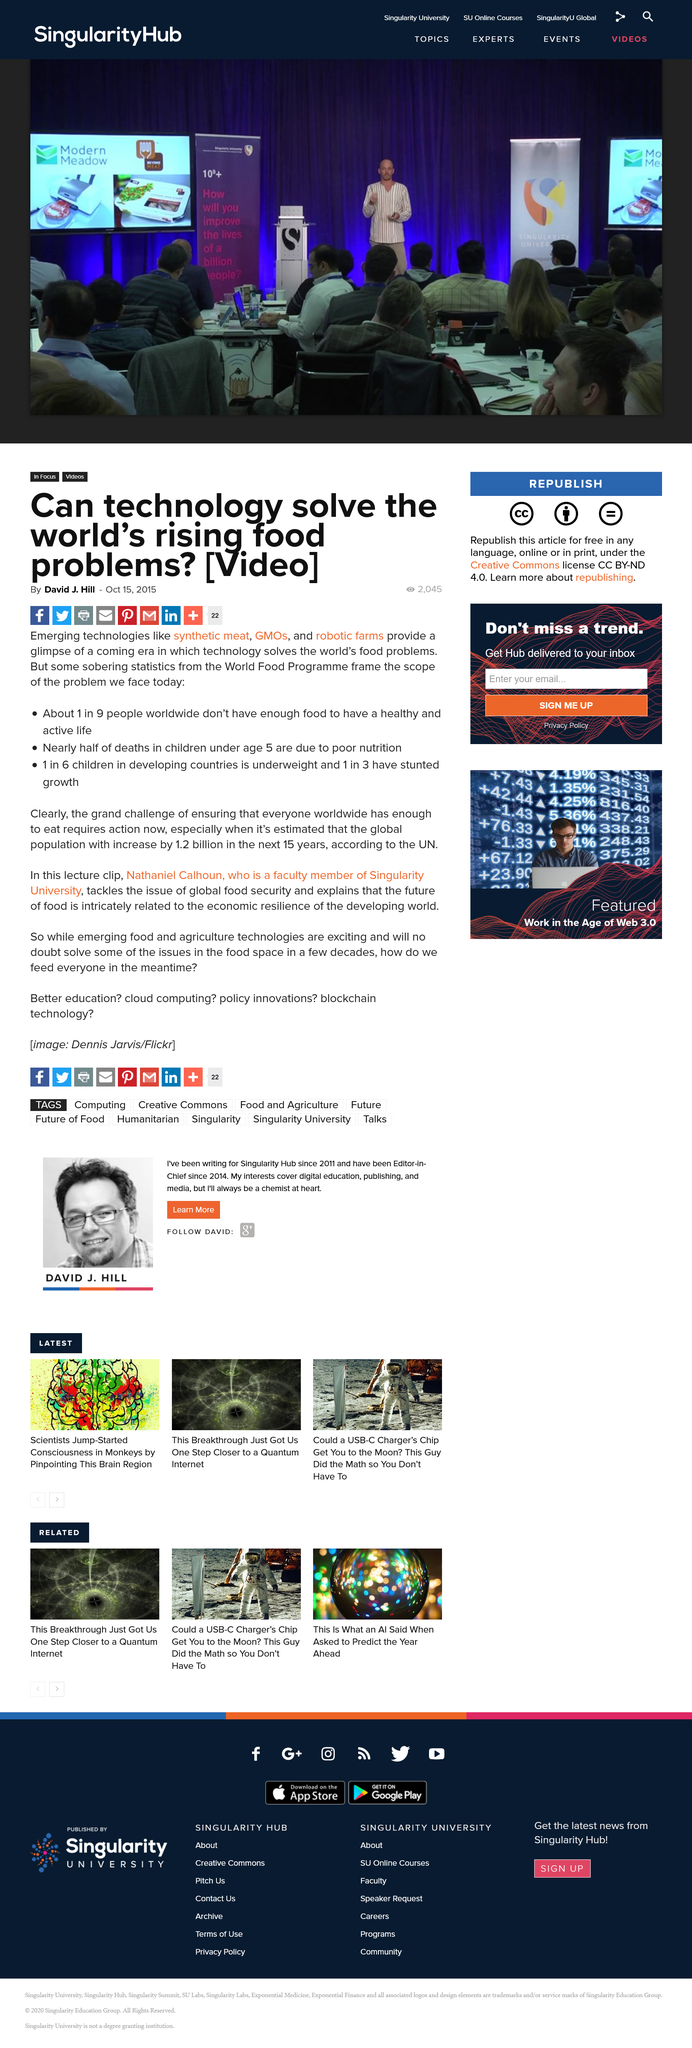Identify some key points in this picture. Poor nutrition is the leading cause of nearly 50% of deaths in children under the age of 5. In developing countries, one in three children are affected by stunted growth, indicating a significant health issue in these regions. Synthetic meat, genetically modified organisms (GMOs), and robotic farms are three examples of emerging technologies that are rapidly gaining popularity in the field of agriculture. These innovative techniques and tools offer numerous benefits, including increased efficiency, reduced costs, and improved crop yields. Additionally, these advancements have the potential to revolutionize the way we approach food production, making it easier and more sustainable to feed a growing global population. 